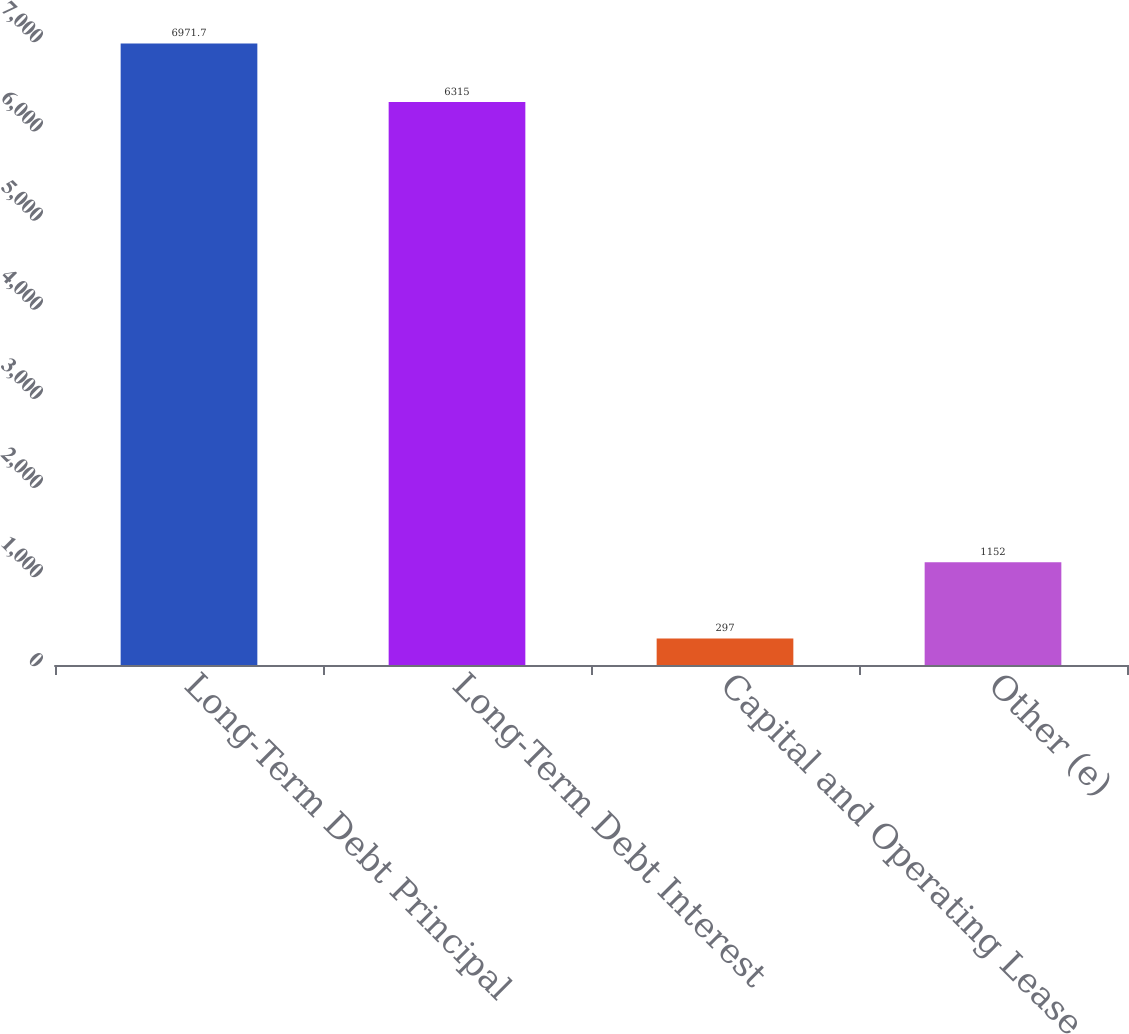<chart> <loc_0><loc_0><loc_500><loc_500><bar_chart><fcel>Long-Term Debt Principal<fcel>Long-Term Debt Interest<fcel>Capital and Operating Lease<fcel>Other (e)<nl><fcel>6971.7<fcel>6315<fcel>297<fcel>1152<nl></chart> 